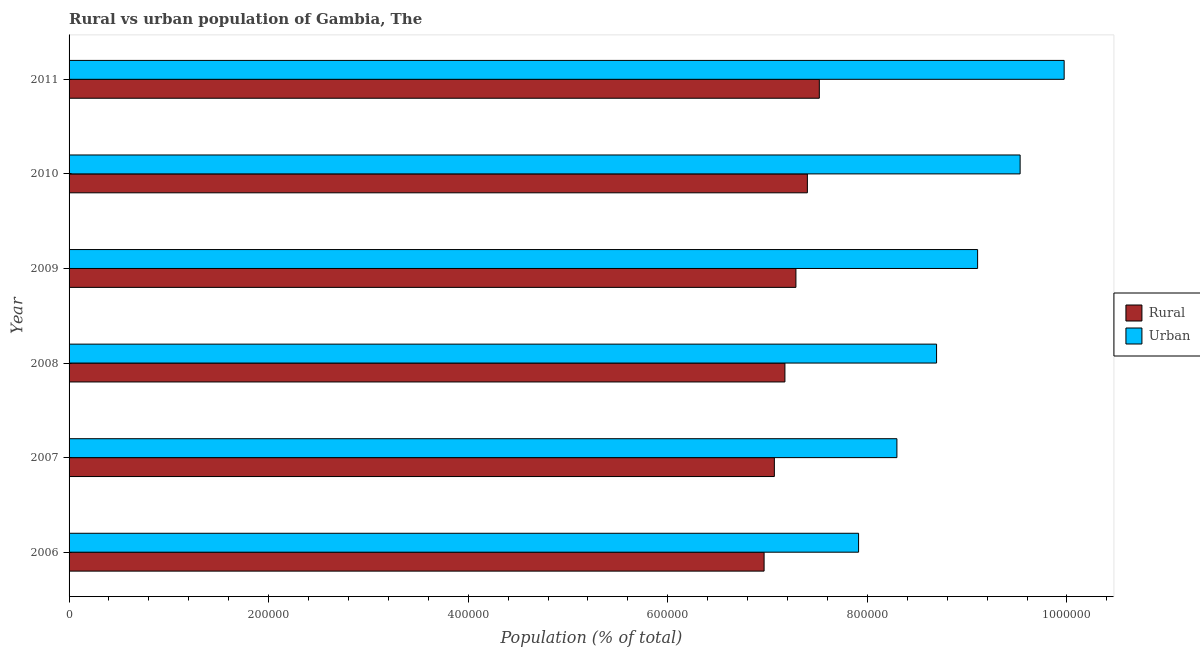How many different coloured bars are there?
Your answer should be very brief. 2. Are the number of bars per tick equal to the number of legend labels?
Offer a very short reply. Yes. Are the number of bars on each tick of the Y-axis equal?
Provide a short and direct response. Yes. What is the label of the 1st group of bars from the top?
Provide a succinct answer. 2011. What is the urban population density in 2008?
Offer a very short reply. 8.69e+05. Across all years, what is the maximum urban population density?
Your answer should be very brief. 9.97e+05. Across all years, what is the minimum rural population density?
Provide a succinct answer. 6.97e+05. In which year was the urban population density maximum?
Offer a very short reply. 2011. What is the total urban population density in the graph?
Keep it short and to the point. 5.35e+06. What is the difference between the rural population density in 2006 and that in 2010?
Give a very brief answer. -4.34e+04. What is the difference between the urban population density in 2008 and the rural population density in 2007?
Keep it short and to the point. 1.63e+05. What is the average rural population density per year?
Offer a very short reply. 7.23e+05. In the year 2011, what is the difference between the urban population density and rural population density?
Provide a short and direct response. 2.45e+05. What is the ratio of the urban population density in 2009 to that in 2010?
Offer a very short reply. 0.95. Is the rural population density in 2008 less than that in 2009?
Keep it short and to the point. Yes. What is the difference between the highest and the second highest urban population density?
Offer a very short reply. 4.41e+04. What is the difference between the highest and the lowest urban population density?
Your answer should be compact. 2.06e+05. In how many years, is the urban population density greater than the average urban population density taken over all years?
Your answer should be very brief. 3. What does the 1st bar from the top in 2010 represents?
Your answer should be compact. Urban. What does the 2nd bar from the bottom in 2011 represents?
Your answer should be very brief. Urban. How many bars are there?
Make the answer very short. 12. Are all the bars in the graph horizontal?
Your answer should be compact. Yes. What is the difference between two consecutive major ticks on the X-axis?
Offer a very short reply. 2.00e+05. Are the values on the major ticks of X-axis written in scientific E-notation?
Your answer should be compact. No. Does the graph contain grids?
Offer a very short reply. No. How are the legend labels stacked?
Your response must be concise. Vertical. What is the title of the graph?
Ensure brevity in your answer.  Rural vs urban population of Gambia, The. What is the label or title of the X-axis?
Give a very brief answer. Population (% of total). What is the Population (% of total) in Rural in 2006?
Provide a succinct answer. 6.97e+05. What is the Population (% of total) of Urban in 2006?
Provide a succinct answer. 7.91e+05. What is the Population (% of total) in Rural in 2007?
Keep it short and to the point. 7.07e+05. What is the Population (% of total) of Urban in 2007?
Give a very brief answer. 8.30e+05. What is the Population (% of total) of Rural in 2008?
Keep it short and to the point. 7.17e+05. What is the Population (% of total) of Urban in 2008?
Make the answer very short. 8.69e+05. What is the Population (% of total) in Rural in 2009?
Make the answer very short. 7.28e+05. What is the Population (% of total) in Urban in 2009?
Give a very brief answer. 9.10e+05. What is the Population (% of total) in Rural in 2010?
Provide a short and direct response. 7.40e+05. What is the Population (% of total) in Urban in 2010?
Your answer should be very brief. 9.53e+05. What is the Population (% of total) of Rural in 2011?
Ensure brevity in your answer.  7.52e+05. What is the Population (% of total) of Urban in 2011?
Offer a terse response. 9.97e+05. Across all years, what is the maximum Population (% of total) of Rural?
Give a very brief answer. 7.52e+05. Across all years, what is the maximum Population (% of total) in Urban?
Your response must be concise. 9.97e+05. Across all years, what is the minimum Population (% of total) in Rural?
Provide a short and direct response. 6.97e+05. Across all years, what is the minimum Population (% of total) of Urban?
Your response must be concise. 7.91e+05. What is the total Population (% of total) in Rural in the graph?
Your answer should be compact. 4.34e+06. What is the total Population (% of total) of Urban in the graph?
Provide a short and direct response. 5.35e+06. What is the difference between the Population (% of total) of Rural in 2006 and that in 2007?
Ensure brevity in your answer.  -1.03e+04. What is the difference between the Population (% of total) of Urban in 2006 and that in 2007?
Provide a short and direct response. -3.84e+04. What is the difference between the Population (% of total) in Rural in 2006 and that in 2008?
Keep it short and to the point. -2.09e+04. What is the difference between the Population (% of total) of Urban in 2006 and that in 2008?
Provide a succinct answer. -7.82e+04. What is the difference between the Population (% of total) of Rural in 2006 and that in 2009?
Provide a short and direct response. -3.19e+04. What is the difference between the Population (% of total) of Urban in 2006 and that in 2009?
Make the answer very short. -1.19e+05. What is the difference between the Population (% of total) in Rural in 2006 and that in 2010?
Your answer should be compact. -4.34e+04. What is the difference between the Population (% of total) in Urban in 2006 and that in 2010?
Provide a succinct answer. -1.62e+05. What is the difference between the Population (% of total) of Rural in 2006 and that in 2011?
Your answer should be compact. -5.53e+04. What is the difference between the Population (% of total) of Urban in 2006 and that in 2011?
Offer a terse response. -2.06e+05. What is the difference between the Population (% of total) of Rural in 2007 and that in 2008?
Your answer should be compact. -1.06e+04. What is the difference between the Population (% of total) of Urban in 2007 and that in 2008?
Your answer should be compact. -3.97e+04. What is the difference between the Population (% of total) of Rural in 2007 and that in 2009?
Keep it short and to the point. -2.16e+04. What is the difference between the Population (% of total) in Urban in 2007 and that in 2009?
Make the answer very short. -8.09e+04. What is the difference between the Population (% of total) of Rural in 2007 and that in 2010?
Give a very brief answer. -3.31e+04. What is the difference between the Population (% of total) of Urban in 2007 and that in 2010?
Your answer should be very brief. -1.23e+05. What is the difference between the Population (% of total) of Rural in 2007 and that in 2011?
Make the answer very short. -4.51e+04. What is the difference between the Population (% of total) of Urban in 2007 and that in 2011?
Ensure brevity in your answer.  -1.68e+05. What is the difference between the Population (% of total) in Rural in 2008 and that in 2009?
Your response must be concise. -1.10e+04. What is the difference between the Population (% of total) of Urban in 2008 and that in 2009?
Provide a succinct answer. -4.11e+04. What is the difference between the Population (% of total) of Rural in 2008 and that in 2010?
Offer a very short reply. -2.25e+04. What is the difference between the Population (% of total) of Urban in 2008 and that in 2010?
Provide a short and direct response. -8.37e+04. What is the difference between the Population (% of total) of Rural in 2008 and that in 2011?
Provide a succinct answer. -3.45e+04. What is the difference between the Population (% of total) in Urban in 2008 and that in 2011?
Offer a terse response. -1.28e+05. What is the difference between the Population (% of total) of Rural in 2009 and that in 2010?
Offer a very short reply. -1.15e+04. What is the difference between the Population (% of total) of Urban in 2009 and that in 2010?
Give a very brief answer. -4.26e+04. What is the difference between the Population (% of total) in Rural in 2009 and that in 2011?
Offer a terse response. -2.35e+04. What is the difference between the Population (% of total) in Urban in 2009 and that in 2011?
Provide a short and direct response. -8.67e+04. What is the difference between the Population (% of total) of Rural in 2010 and that in 2011?
Your answer should be compact. -1.20e+04. What is the difference between the Population (% of total) in Urban in 2010 and that in 2011?
Keep it short and to the point. -4.41e+04. What is the difference between the Population (% of total) in Rural in 2006 and the Population (% of total) in Urban in 2007?
Keep it short and to the point. -1.33e+05. What is the difference between the Population (% of total) in Rural in 2006 and the Population (% of total) in Urban in 2008?
Your answer should be compact. -1.73e+05. What is the difference between the Population (% of total) of Rural in 2006 and the Population (% of total) of Urban in 2009?
Offer a terse response. -2.14e+05. What is the difference between the Population (% of total) in Rural in 2006 and the Population (% of total) in Urban in 2010?
Give a very brief answer. -2.57e+05. What is the difference between the Population (% of total) of Rural in 2006 and the Population (% of total) of Urban in 2011?
Offer a very short reply. -3.01e+05. What is the difference between the Population (% of total) of Rural in 2007 and the Population (% of total) of Urban in 2008?
Your answer should be compact. -1.63e+05. What is the difference between the Population (% of total) of Rural in 2007 and the Population (% of total) of Urban in 2009?
Your answer should be very brief. -2.04e+05. What is the difference between the Population (% of total) of Rural in 2007 and the Population (% of total) of Urban in 2010?
Offer a terse response. -2.46e+05. What is the difference between the Population (% of total) of Rural in 2007 and the Population (% of total) of Urban in 2011?
Offer a very short reply. -2.90e+05. What is the difference between the Population (% of total) of Rural in 2008 and the Population (% of total) of Urban in 2009?
Keep it short and to the point. -1.93e+05. What is the difference between the Population (% of total) in Rural in 2008 and the Population (% of total) in Urban in 2010?
Your response must be concise. -2.36e+05. What is the difference between the Population (% of total) in Rural in 2008 and the Population (% of total) in Urban in 2011?
Offer a terse response. -2.80e+05. What is the difference between the Population (% of total) of Rural in 2009 and the Population (% of total) of Urban in 2010?
Offer a very short reply. -2.25e+05. What is the difference between the Population (% of total) of Rural in 2009 and the Population (% of total) of Urban in 2011?
Offer a terse response. -2.69e+05. What is the difference between the Population (% of total) of Rural in 2010 and the Population (% of total) of Urban in 2011?
Your answer should be compact. -2.57e+05. What is the average Population (% of total) in Rural per year?
Make the answer very short. 7.23e+05. What is the average Population (% of total) of Urban per year?
Ensure brevity in your answer.  8.92e+05. In the year 2006, what is the difference between the Population (% of total) in Rural and Population (% of total) in Urban?
Provide a short and direct response. -9.47e+04. In the year 2007, what is the difference between the Population (% of total) in Rural and Population (% of total) in Urban?
Ensure brevity in your answer.  -1.23e+05. In the year 2008, what is the difference between the Population (% of total) in Rural and Population (% of total) in Urban?
Offer a very short reply. -1.52e+05. In the year 2009, what is the difference between the Population (% of total) in Rural and Population (% of total) in Urban?
Offer a very short reply. -1.82e+05. In the year 2010, what is the difference between the Population (% of total) of Rural and Population (% of total) of Urban?
Ensure brevity in your answer.  -2.13e+05. In the year 2011, what is the difference between the Population (% of total) of Rural and Population (% of total) of Urban?
Ensure brevity in your answer.  -2.45e+05. What is the ratio of the Population (% of total) in Rural in 2006 to that in 2007?
Ensure brevity in your answer.  0.99. What is the ratio of the Population (% of total) of Urban in 2006 to that in 2007?
Your response must be concise. 0.95. What is the ratio of the Population (% of total) of Rural in 2006 to that in 2008?
Make the answer very short. 0.97. What is the ratio of the Population (% of total) in Urban in 2006 to that in 2008?
Offer a terse response. 0.91. What is the ratio of the Population (% of total) of Rural in 2006 to that in 2009?
Make the answer very short. 0.96. What is the ratio of the Population (% of total) of Urban in 2006 to that in 2009?
Offer a terse response. 0.87. What is the ratio of the Population (% of total) of Rural in 2006 to that in 2010?
Keep it short and to the point. 0.94. What is the ratio of the Population (% of total) in Urban in 2006 to that in 2010?
Your response must be concise. 0.83. What is the ratio of the Population (% of total) in Rural in 2006 to that in 2011?
Offer a terse response. 0.93. What is the ratio of the Population (% of total) in Urban in 2006 to that in 2011?
Make the answer very short. 0.79. What is the ratio of the Population (% of total) of Rural in 2007 to that in 2008?
Your answer should be very brief. 0.99. What is the ratio of the Population (% of total) in Urban in 2007 to that in 2008?
Offer a very short reply. 0.95. What is the ratio of the Population (% of total) in Rural in 2007 to that in 2009?
Make the answer very short. 0.97. What is the ratio of the Population (% of total) in Urban in 2007 to that in 2009?
Your answer should be compact. 0.91. What is the ratio of the Population (% of total) in Rural in 2007 to that in 2010?
Offer a very short reply. 0.96. What is the ratio of the Population (% of total) in Urban in 2007 to that in 2010?
Keep it short and to the point. 0.87. What is the ratio of the Population (% of total) in Rural in 2007 to that in 2011?
Keep it short and to the point. 0.94. What is the ratio of the Population (% of total) in Urban in 2007 to that in 2011?
Your answer should be compact. 0.83. What is the ratio of the Population (% of total) of Rural in 2008 to that in 2009?
Offer a very short reply. 0.98. What is the ratio of the Population (% of total) in Urban in 2008 to that in 2009?
Give a very brief answer. 0.95. What is the ratio of the Population (% of total) in Rural in 2008 to that in 2010?
Give a very brief answer. 0.97. What is the ratio of the Population (% of total) in Urban in 2008 to that in 2010?
Offer a very short reply. 0.91. What is the ratio of the Population (% of total) in Rural in 2008 to that in 2011?
Give a very brief answer. 0.95. What is the ratio of the Population (% of total) in Urban in 2008 to that in 2011?
Offer a very short reply. 0.87. What is the ratio of the Population (% of total) of Rural in 2009 to that in 2010?
Keep it short and to the point. 0.98. What is the ratio of the Population (% of total) in Urban in 2009 to that in 2010?
Your answer should be very brief. 0.96. What is the ratio of the Population (% of total) in Rural in 2009 to that in 2011?
Make the answer very short. 0.97. What is the ratio of the Population (% of total) in Rural in 2010 to that in 2011?
Ensure brevity in your answer.  0.98. What is the ratio of the Population (% of total) in Urban in 2010 to that in 2011?
Provide a succinct answer. 0.96. What is the difference between the highest and the second highest Population (% of total) of Rural?
Your answer should be very brief. 1.20e+04. What is the difference between the highest and the second highest Population (% of total) in Urban?
Make the answer very short. 4.41e+04. What is the difference between the highest and the lowest Population (% of total) of Rural?
Your response must be concise. 5.53e+04. What is the difference between the highest and the lowest Population (% of total) in Urban?
Ensure brevity in your answer.  2.06e+05. 